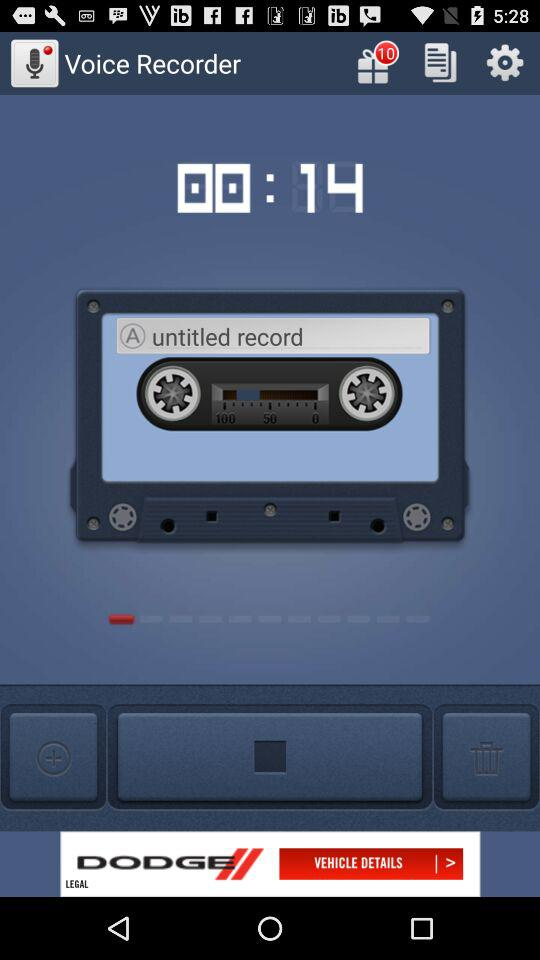What is the duration of the voice recording? The duration of the voice recording is 14 seconds. 